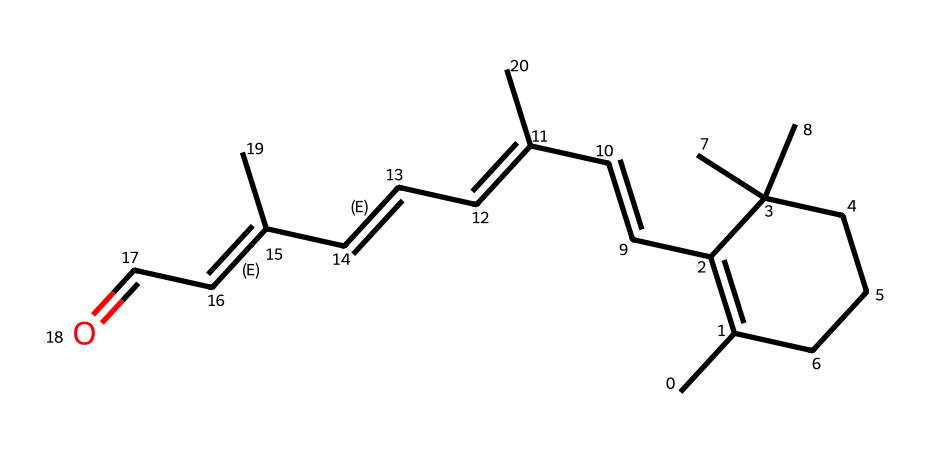What is the name of this chemical? The provided SMILES corresponds to retinal, a derivative of vitamin A, commonly known to be involved in the vision process in animals.
Answer: retinal How many carbon atoms are in retinal? By analyzing the SMILES representation, we count the carbon atoms indicated before and after the C in the structure, resulting in a total count of 20 carbon atoms.
Answer: 20 What type of isomerism is exhibited by retinal? The presence of cis and trans configurations in retinal, determined by the placement of substituents around double bonds, indicates that it exhibits geometric isomerism.
Answer: geometric isomerism What functional group is present in retinal? The appearance of 'C=O' in the SMILES indicates the presence of an aldehyde functional group, which is a characteristic feature of retinal.
Answer: aldehyde How many double bonds are present in retinal? By examining the structure derived from the SMILES, we can identify the double bonds; there are 4 double bonds observed within retinal.
Answer: 4 Which part of retinal is responsible for its light sensitivity? The system of conjugated double bonds across the structure of retinal allows it to absorb light, which is crucial for its role in vision.
Answer: conjugated double bonds 